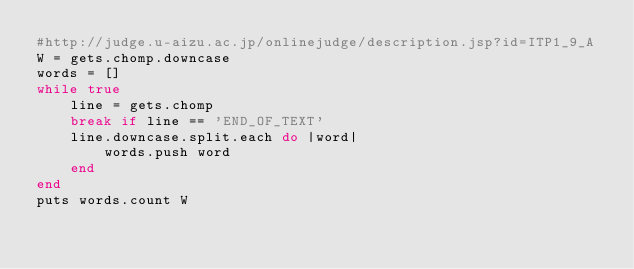Convert code to text. <code><loc_0><loc_0><loc_500><loc_500><_Ruby_>#http://judge.u-aizu.ac.jp/onlinejudge/description.jsp?id=ITP1_9_A
W = gets.chomp.downcase
words = []
while true
    line = gets.chomp
    break if line == 'END_OF_TEXT'
    line.downcase.split.each do |word|
        words.push word
    end
end
puts words.count W</code> 